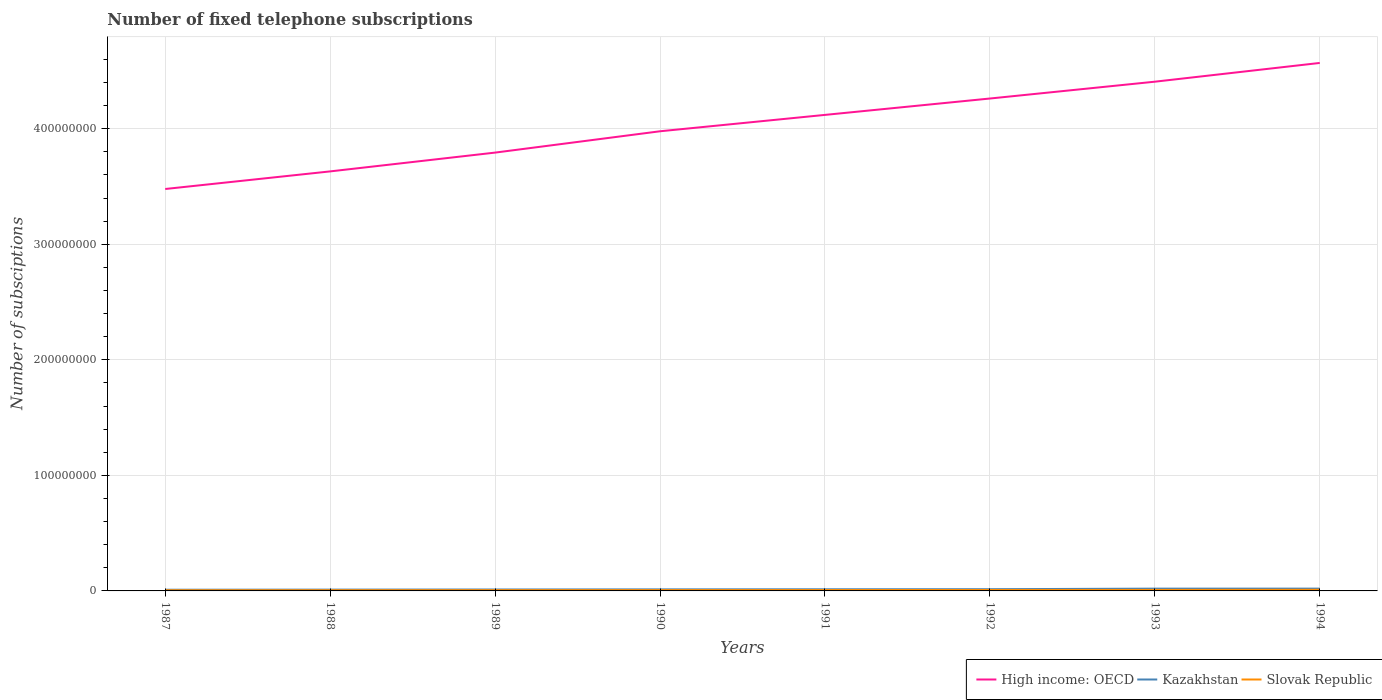Does the line corresponding to Slovak Republic intersect with the line corresponding to Kazakhstan?
Your answer should be compact. No. Is the number of lines equal to the number of legend labels?
Keep it short and to the point. Yes. Across all years, what is the maximum number of fixed telephone subscriptions in Kazakhstan?
Keep it short and to the point. 1.02e+06. In which year was the number of fixed telephone subscriptions in Slovak Republic maximum?
Your answer should be very brief. 1987. What is the total number of fixed telephone subscriptions in Slovak Republic in the graph?
Give a very brief answer. -2.99e+05. What is the difference between the highest and the second highest number of fixed telephone subscriptions in High income: OECD?
Your response must be concise. 1.09e+08. What is the difference between two consecutive major ticks on the Y-axis?
Offer a terse response. 1.00e+08. Does the graph contain any zero values?
Give a very brief answer. No. Does the graph contain grids?
Offer a very short reply. Yes. How many legend labels are there?
Your answer should be compact. 3. How are the legend labels stacked?
Ensure brevity in your answer.  Horizontal. What is the title of the graph?
Offer a very short reply. Number of fixed telephone subscriptions. Does "World" appear as one of the legend labels in the graph?
Provide a succinct answer. No. What is the label or title of the Y-axis?
Make the answer very short. Number of subsciptions. What is the Number of subsciptions of High income: OECD in 1987?
Your answer should be compact. 3.48e+08. What is the Number of subsciptions of Kazakhstan in 1987?
Your response must be concise. 1.02e+06. What is the Number of subsciptions in Slovak Republic in 1987?
Give a very brief answer. 5.94e+05. What is the Number of subsciptions in High income: OECD in 1988?
Your response must be concise. 3.63e+08. What is the Number of subsciptions of Kazakhstan in 1988?
Your response must be concise. 1.12e+06. What is the Number of subsciptions in Slovak Republic in 1988?
Provide a short and direct response. 6.29e+05. What is the Number of subsciptions in High income: OECD in 1989?
Offer a terse response. 3.79e+08. What is the Number of subsciptions in Kazakhstan in 1989?
Give a very brief answer. 1.23e+06. What is the Number of subsciptions in Slovak Republic in 1989?
Provide a succinct answer. 6.69e+05. What is the Number of subsciptions in High income: OECD in 1990?
Your answer should be compact. 3.98e+08. What is the Number of subsciptions of Kazakhstan in 1990?
Offer a very short reply. 1.33e+06. What is the Number of subsciptions in Slovak Republic in 1990?
Your answer should be compact. 7.11e+05. What is the Number of subsciptions of High income: OECD in 1991?
Provide a succinct answer. 4.12e+08. What is the Number of subsciptions of Kazakhstan in 1991?
Your answer should be compact. 1.43e+06. What is the Number of subsciptions of Slovak Republic in 1991?
Offer a terse response. 7.59e+05. What is the Number of subsciptions in High income: OECD in 1992?
Your answer should be very brief. 4.26e+08. What is the Number of subsciptions of Kazakhstan in 1992?
Ensure brevity in your answer.  1.49e+06. What is the Number of subsciptions in Slovak Republic in 1992?
Give a very brief answer. 8.21e+05. What is the Number of subsciptions in High income: OECD in 1993?
Offer a very short reply. 4.41e+08. What is the Number of subsciptions in Kazakhstan in 1993?
Your answer should be compact. 1.98e+06. What is the Number of subsciptions of Slovak Republic in 1993?
Provide a succinct answer. 8.93e+05. What is the Number of subsciptions in High income: OECD in 1994?
Your answer should be very brief. 4.57e+08. What is the Number of subsciptions of Kazakhstan in 1994?
Provide a short and direct response. 1.99e+06. What is the Number of subsciptions in Slovak Republic in 1994?
Provide a succinct answer. 1.00e+06. Across all years, what is the maximum Number of subsciptions in High income: OECD?
Provide a short and direct response. 4.57e+08. Across all years, what is the maximum Number of subsciptions of Kazakhstan?
Your answer should be compact. 1.99e+06. Across all years, what is the maximum Number of subsciptions in Slovak Republic?
Provide a succinct answer. 1.00e+06. Across all years, what is the minimum Number of subsciptions of High income: OECD?
Keep it short and to the point. 3.48e+08. Across all years, what is the minimum Number of subsciptions in Kazakhstan?
Your response must be concise. 1.02e+06. Across all years, what is the minimum Number of subsciptions in Slovak Republic?
Keep it short and to the point. 5.94e+05. What is the total Number of subsciptions in High income: OECD in the graph?
Your answer should be compact. 3.22e+09. What is the total Number of subsciptions of Kazakhstan in the graph?
Provide a short and direct response. 1.16e+07. What is the total Number of subsciptions of Slovak Republic in the graph?
Offer a very short reply. 6.08e+06. What is the difference between the Number of subsciptions in High income: OECD in 1987 and that in 1988?
Your answer should be very brief. -1.52e+07. What is the difference between the Number of subsciptions in Kazakhstan in 1987 and that in 1988?
Your answer should be compact. -9.51e+04. What is the difference between the Number of subsciptions of Slovak Republic in 1987 and that in 1988?
Give a very brief answer. -3.54e+04. What is the difference between the Number of subsciptions in High income: OECD in 1987 and that in 1989?
Offer a terse response. -3.15e+07. What is the difference between the Number of subsciptions of Kazakhstan in 1987 and that in 1989?
Keep it short and to the point. -2.02e+05. What is the difference between the Number of subsciptions of Slovak Republic in 1987 and that in 1989?
Your answer should be very brief. -7.51e+04. What is the difference between the Number of subsciptions in High income: OECD in 1987 and that in 1990?
Provide a succinct answer. -5.00e+07. What is the difference between the Number of subsciptions of Kazakhstan in 1987 and that in 1990?
Your response must be concise. -3.10e+05. What is the difference between the Number of subsciptions in Slovak Republic in 1987 and that in 1990?
Give a very brief answer. -1.17e+05. What is the difference between the Number of subsciptions in High income: OECD in 1987 and that in 1991?
Your response must be concise. -6.41e+07. What is the difference between the Number of subsciptions in Kazakhstan in 1987 and that in 1991?
Offer a very short reply. -4.01e+05. What is the difference between the Number of subsciptions of Slovak Republic in 1987 and that in 1991?
Provide a succinct answer. -1.65e+05. What is the difference between the Number of subsciptions of High income: OECD in 1987 and that in 1992?
Keep it short and to the point. -7.83e+07. What is the difference between the Number of subsciptions of Kazakhstan in 1987 and that in 1992?
Provide a short and direct response. -4.67e+05. What is the difference between the Number of subsciptions in Slovak Republic in 1987 and that in 1992?
Provide a succinct answer. -2.27e+05. What is the difference between the Number of subsciptions of High income: OECD in 1987 and that in 1993?
Your answer should be very brief. -9.29e+07. What is the difference between the Number of subsciptions in Kazakhstan in 1987 and that in 1993?
Your response must be concise. -9.52e+05. What is the difference between the Number of subsciptions of Slovak Republic in 1987 and that in 1993?
Your answer should be compact. -2.99e+05. What is the difference between the Number of subsciptions of High income: OECD in 1987 and that in 1994?
Your answer should be very brief. -1.09e+08. What is the difference between the Number of subsciptions of Kazakhstan in 1987 and that in 1994?
Offer a very short reply. -9.63e+05. What is the difference between the Number of subsciptions in Slovak Republic in 1987 and that in 1994?
Offer a terse response. -4.10e+05. What is the difference between the Number of subsciptions of High income: OECD in 1988 and that in 1989?
Give a very brief answer. -1.63e+07. What is the difference between the Number of subsciptions of Kazakhstan in 1988 and that in 1989?
Your answer should be very brief. -1.07e+05. What is the difference between the Number of subsciptions in Slovak Republic in 1988 and that in 1989?
Provide a succinct answer. -3.97e+04. What is the difference between the Number of subsciptions of High income: OECD in 1988 and that in 1990?
Your answer should be very brief. -3.47e+07. What is the difference between the Number of subsciptions of Kazakhstan in 1988 and that in 1990?
Keep it short and to the point. -2.15e+05. What is the difference between the Number of subsciptions of Slovak Republic in 1988 and that in 1990?
Your answer should be very brief. -8.17e+04. What is the difference between the Number of subsciptions in High income: OECD in 1988 and that in 1991?
Provide a succinct answer. -4.89e+07. What is the difference between the Number of subsciptions in Kazakhstan in 1988 and that in 1991?
Your answer should be compact. -3.06e+05. What is the difference between the Number of subsciptions of Slovak Republic in 1988 and that in 1991?
Offer a very short reply. -1.30e+05. What is the difference between the Number of subsciptions in High income: OECD in 1988 and that in 1992?
Offer a very short reply. -6.31e+07. What is the difference between the Number of subsciptions of Kazakhstan in 1988 and that in 1992?
Offer a terse response. -3.71e+05. What is the difference between the Number of subsciptions of Slovak Republic in 1988 and that in 1992?
Offer a very short reply. -1.92e+05. What is the difference between the Number of subsciptions of High income: OECD in 1988 and that in 1993?
Offer a very short reply. -7.76e+07. What is the difference between the Number of subsciptions in Kazakhstan in 1988 and that in 1993?
Keep it short and to the point. -8.57e+05. What is the difference between the Number of subsciptions in Slovak Republic in 1988 and that in 1993?
Provide a short and direct response. -2.64e+05. What is the difference between the Number of subsciptions in High income: OECD in 1988 and that in 1994?
Offer a terse response. -9.39e+07. What is the difference between the Number of subsciptions of Kazakhstan in 1988 and that in 1994?
Ensure brevity in your answer.  -8.68e+05. What is the difference between the Number of subsciptions of Slovak Republic in 1988 and that in 1994?
Make the answer very short. -3.75e+05. What is the difference between the Number of subsciptions in High income: OECD in 1989 and that in 1990?
Your response must be concise. -1.85e+07. What is the difference between the Number of subsciptions of Kazakhstan in 1989 and that in 1990?
Offer a terse response. -1.08e+05. What is the difference between the Number of subsciptions of Slovak Republic in 1989 and that in 1990?
Offer a very short reply. -4.19e+04. What is the difference between the Number of subsciptions in High income: OECD in 1989 and that in 1991?
Provide a short and direct response. -3.26e+07. What is the difference between the Number of subsciptions in Kazakhstan in 1989 and that in 1991?
Ensure brevity in your answer.  -2.00e+05. What is the difference between the Number of subsciptions of Slovak Republic in 1989 and that in 1991?
Your response must be concise. -9.01e+04. What is the difference between the Number of subsciptions in High income: OECD in 1989 and that in 1992?
Provide a succinct answer. -4.68e+07. What is the difference between the Number of subsciptions in Kazakhstan in 1989 and that in 1992?
Keep it short and to the point. -2.65e+05. What is the difference between the Number of subsciptions of Slovak Republic in 1989 and that in 1992?
Offer a very short reply. -1.52e+05. What is the difference between the Number of subsciptions of High income: OECD in 1989 and that in 1993?
Give a very brief answer. -6.14e+07. What is the difference between the Number of subsciptions in Kazakhstan in 1989 and that in 1993?
Your response must be concise. -7.50e+05. What is the difference between the Number of subsciptions in Slovak Republic in 1989 and that in 1993?
Keep it short and to the point. -2.24e+05. What is the difference between the Number of subsciptions in High income: OECD in 1989 and that in 1994?
Keep it short and to the point. -7.76e+07. What is the difference between the Number of subsciptions in Kazakhstan in 1989 and that in 1994?
Ensure brevity in your answer.  -7.61e+05. What is the difference between the Number of subsciptions of Slovak Republic in 1989 and that in 1994?
Provide a short and direct response. -3.35e+05. What is the difference between the Number of subsciptions in High income: OECD in 1990 and that in 1991?
Provide a succinct answer. -1.42e+07. What is the difference between the Number of subsciptions of Kazakhstan in 1990 and that in 1991?
Ensure brevity in your answer.  -9.18e+04. What is the difference between the Number of subsciptions in Slovak Republic in 1990 and that in 1991?
Ensure brevity in your answer.  -4.82e+04. What is the difference between the Number of subsciptions of High income: OECD in 1990 and that in 1992?
Provide a succinct answer. -2.84e+07. What is the difference between the Number of subsciptions of Kazakhstan in 1990 and that in 1992?
Provide a succinct answer. -1.57e+05. What is the difference between the Number of subsciptions of Slovak Republic in 1990 and that in 1992?
Your answer should be very brief. -1.10e+05. What is the difference between the Number of subsciptions in High income: OECD in 1990 and that in 1993?
Your response must be concise. -4.29e+07. What is the difference between the Number of subsciptions of Kazakhstan in 1990 and that in 1993?
Offer a very short reply. -6.42e+05. What is the difference between the Number of subsciptions in Slovak Republic in 1990 and that in 1993?
Provide a short and direct response. -1.82e+05. What is the difference between the Number of subsciptions in High income: OECD in 1990 and that in 1994?
Provide a succinct answer. -5.91e+07. What is the difference between the Number of subsciptions of Kazakhstan in 1990 and that in 1994?
Give a very brief answer. -6.54e+05. What is the difference between the Number of subsciptions in Slovak Republic in 1990 and that in 1994?
Ensure brevity in your answer.  -2.93e+05. What is the difference between the Number of subsciptions of High income: OECD in 1991 and that in 1992?
Offer a very short reply. -1.42e+07. What is the difference between the Number of subsciptions in Kazakhstan in 1991 and that in 1992?
Ensure brevity in your answer.  -6.52e+04. What is the difference between the Number of subsciptions in Slovak Republic in 1991 and that in 1992?
Your response must be concise. -6.19e+04. What is the difference between the Number of subsciptions of High income: OECD in 1991 and that in 1993?
Offer a terse response. -2.87e+07. What is the difference between the Number of subsciptions in Kazakhstan in 1991 and that in 1993?
Provide a succinct answer. -5.51e+05. What is the difference between the Number of subsciptions of Slovak Republic in 1991 and that in 1993?
Keep it short and to the point. -1.34e+05. What is the difference between the Number of subsciptions of High income: OECD in 1991 and that in 1994?
Provide a succinct answer. -4.50e+07. What is the difference between the Number of subsciptions of Kazakhstan in 1991 and that in 1994?
Your response must be concise. -5.62e+05. What is the difference between the Number of subsciptions of Slovak Republic in 1991 and that in 1994?
Give a very brief answer. -2.45e+05. What is the difference between the Number of subsciptions of High income: OECD in 1992 and that in 1993?
Give a very brief answer. -1.46e+07. What is the difference between the Number of subsciptions in Kazakhstan in 1992 and that in 1993?
Keep it short and to the point. -4.85e+05. What is the difference between the Number of subsciptions of Slovak Republic in 1992 and that in 1993?
Keep it short and to the point. -7.19e+04. What is the difference between the Number of subsciptions of High income: OECD in 1992 and that in 1994?
Give a very brief answer. -3.08e+07. What is the difference between the Number of subsciptions in Kazakhstan in 1992 and that in 1994?
Give a very brief answer. -4.97e+05. What is the difference between the Number of subsciptions of Slovak Republic in 1992 and that in 1994?
Keep it short and to the point. -1.83e+05. What is the difference between the Number of subsciptions of High income: OECD in 1993 and that in 1994?
Offer a very short reply. -1.62e+07. What is the difference between the Number of subsciptions in Kazakhstan in 1993 and that in 1994?
Keep it short and to the point. -1.12e+04. What is the difference between the Number of subsciptions of Slovak Republic in 1993 and that in 1994?
Offer a terse response. -1.11e+05. What is the difference between the Number of subsciptions in High income: OECD in 1987 and the Number of subsciptions in Kazakhstan in 1988?
Offer a very short reply. 3.47e+08. What is the difference between the Number of subsciptions of High income: OECD in 1987 and the Number of subsciptions of Slovak Republic in 1988?
Your response must be concise. 3.47e+08. What is the difference between the Number of subsciptions in Kazakhstan in 1987 and the Number of subsciptions in Slovak Republic in 1988?
Make the answer very short. 3.95e+05. What is the difference between the Number of subsciptions of High income: OECD in 1987 and the Number of subsciptions of Kazakhstan in 1989?
Provide a short and direct response. 3.47e+08. What is the difference between the Number of subsciptions of High income: OECD in 1987 and the Number of subsciptions of Slovak Republic in 1989?
Provide a succinct answer. 3.47e+08. What is the difference between the Number of subsciptions in Kazakhstan in 1987 and the Number of subsciptions in Slovak Republic in 1989?
Provide a short and direct response. 3.55e+05. What is the difference between the Number of subsciptions in High income: OECD in 1987 and the Number of subsciptions in Kazakhstan in 1990?
Give a very brief answer. 3.47e+08. What is the difference between the Number of subsciptions of High income: OECD in 1987 and the Number of subsciptions of Slovak Republic in 1990?
Offer a terse response. 3.47e+08. What is the difference between the Number of subsciptions in Kazakhstan in 1987 and the Number of subsciptions in Slovak Republic in 1990?
Your response must be concise. 3.13e+05. What is the difference between the Number of subsciptions in High income: OECD in 1987 and the Number of subsciptions in Kazakhstan in 1991?
Make the answer very short. 3.46e+08. What is the difference between the Number of subsciptions of High income: OECD in 1987 and the Number of subsciptions of Slovak Republic in 1991?
Provide a short and direct response. 3.47e+08. What is the difference between the Number of subsciptions of Kazakhstan in 1987 and the Number of subsciptions of Slovak Republic in 1991?
Your answer should be compact. 2.65e+05. What is the difference between the Number of subsciptions in High income: OECD in 1987 and the Number of subsciptions in Kazakhstan in 1992?
Keep it short and to the point. 3.46e+08. What is the difference between the Number of subsciptions in High income: OECD in 1987 and the Number of subsciptions in Slovak Republic in 1992?
Give a very brief answer. 3.47e+08. What is the difference between the Number of subsciptions in Kazakhstan in 1987 and the Number of subsciptions in Slovak Republic in 1992?
Your answer should be compact. 2.03e+05. What is the difference between the Number of subsciptions in High income: OECD in 1987 and the Number of subsciptions in Kazakhstan in 1993?
Keep it short and to the point. 3.46e+08. What is the difference between the Number of subsciptions of High income: OECD in 1987 and the Number of subsciptions of Slovak Republic in 1993?
Ensure brevity in your answer.  3.47e+08. What is the difference between the Number of subsciptions of Kazakhstan in 1987 and the Number of subsciptions of Slovak Republic in 1993?
Provide a succinct answer. 1.31e+05. What is the difference between the Number of subsciptions in High income: OECD in 1987 and the Number of subsciptions in Kazakhstan in 1994?
Make the answer very short. 3.46e+08. What is the difference between the Number of subsciptions in High income: OECD in 1987 and the Number of subsciptions in Slovak Republic in 1994?
Provide a succinct answer. 3.47e+08. What is the difference between the Number of subsciptions of Kazakhstan in 1987 and the Number of subsciptions of Slovak Republic in 1994?
Make the answer very short. 2.00e+04. What is the difference between the Number of subsciptions in High income: OECD in 1988 and the Number of subsciptions in Kazakhstan in 1989?
Offer a terse response. 3.62e+08. What is the difference between the Number of subsciptions in High income: OECD in 1988 and the Number of subsciptions in Slovak Republic in 1989?
Your answer should be very brief. 3.62e+08. What is the difference between the Number of subsciptions in Kazakhstan in 1988 and the Number of subsciptions in Slovak Republic in 1989?
Ensure brevity in your answer.  4.50e+05. What is the difference between the Number of subsciptions in High income: OECD in 1988 and the Number of subsciptions in Kazakhstan in 1990?
Make the answer very short. 3.62e+08. What is the difference between the Number of subsciptions of High income: OECD in 1988 and the Number of subsciptions of Slovak Republic in 1990?
Keep it short and to the point. 3.62e+08. What is the difference between the Number of subsciptions of Kazakhstan in 1988 and the Number of subsciptions of Slovak Republic in 1990?
Offer a very short reply. 4.08e+05. What is the difference between the Number of subsciptions of High income: OECD in 1988 and the Number of subsciptions of Kazakhstan in 1991?
Keep it short and to the point. 3.62e+08. What is the difference between the Number of subsciptions of High income: OECD in 1988 and the Number of subsciptions of Slovak Republic in 1991?
Keep it short and to the point. 3.62e+08. What is the difference between the Number of subsciptions in Kazakhstan in 1988 and the Number of subsciptions in Slovak Republic in 1991?
Give a very brief answer. 3.60e+05. What is the difference between the Number of subsciptions in High income: OECD in 1988 and the Number of subsciptions in Kazakhstan in 1992?
Your response must be concise. 3.62e+08. What is the difference between the Number of subsciptions of High income: OECD in 1988 and the Number of subsciptions of Slovak Republic in 1992?
Make the answer very short. 3.62e+08. What is the difference between the Number of subsciptions of Kazakhstan in 1988 and the Number of subsciptions of Slovak Republic in 1992?
Give a very brief answer. 2.98e+05. What is the difference between the Number of subsciptions of High income: OECD in 1988 and the Number of subsciptions of Kazakhstan in 1993?
Provide a succinct answer. 3.61e+08. What is the difference between the Number of subsciptions of High income: OECD in 1988 and the Number of subsciptions of Slovak Republic in 1993?
Your answer should be compact. 3.62e+08. What is the difference between the Number of subsciptions of Kazakhstan in 1988 and the Number of subsciptions of Slovak Republic in 1993?
Provide a short and direct response. 2.26e+05. What is the difference between the Number of subsciptions in High income: OECD in 1988 and the Number of subsciptions in Kazakhstan in 1994?
Offer a terse response. 3.61e+08. What is the difference between the Number of subsciptions in High income: OECD in 1988 and the Number of subsciptions in Slovak Republic in 1994?
Your response must be concise. 3.62e+08. What is the difference between the Number of subsciptions of Kazakhstan in 1988 and the Number of subsciptions of Slovak Republic in 1994?
Give a very brief answer. 1.15e+05. What is the difference between the Number of subsciptions of High income: OECD in 1989 and the Number of subsciptions of Kazakhstan in 1990?
Provide a short and direct response. 3.78e+08. What is the difference between the Number of subsciptions of High income: OECD in 1989 and the Number of subsciptions of Slovak Republic in 1990?
Give a very brief answer. 3.79e+08. What is the difference between the Number of subsciptions in Kazakhstan in 1989 and the Number of subsciptions in Slovak Republic in 1990?
Provide a succinct answer. 5.15e+05. What is the difference between the Number of subsciptions of High income: OECD in 1989 and the Number of subsciptions of Kazakhstan in 1991?
Make the answer very short. 3.78e+08. What is the difference between the Number of subsciptions in High income: OECD in 1989 and the Number of subsciptions in Slovak Republic in 1991?
Your answer should be compact. 3.79e+08. What is the difference between the Number of subsciptions in Kazakhstan in 1989 and the Number of subsciptions in Slovak Republic in 1991?
Offer a terse response. 4.67e+05. What is the difference between the Number of subsciptions in High income: OECD in 1989 and the Number of subsciptions in Kazakhstan in 1992?
Ensure brevity in your answer.  3.78e+08. What is the difference between the Number of subsciptions in High income: OECD in 1989 and the Number of subsciptions in Slovak Republic in 1992?
Your answer should be compact. 3.79e+08. What is the difference between the Number of subsciptions of Kazakhstan in 1989 and the Number of subsciptions of Slovak Republic in 1992?
Offer a very short reply. 4.05e+05. What is the difference between the Number of subsciptions of High income: OECD in 1989 and the Number of subsciptions of Kazakhstan in 1993?
Offer a very short reply. 3.77e+08. What is the difference between the Number of subsciptions in High income: OECD in 1989 and the Number of subsciptions in Slovak Republic in 1993?
Offer a terse response. 3.78e+08. What is the difference between the Number of subsciptions in Kazakhstan in 1989 and the Number of subsciptions in Slovak Republic in 1993?
Your answer should be compact. 3.33e+05. What is the difference between the Number of subsciptions of High income: OECD in 1989 and the Number of subsciptions of Kazakhstan in 1994?
Ensure brevity in your answer.  3.77e+08. What is the difference between the Number of subsciptions in High income: OECD in 1989 and the Number of subsciptions in Slovak Republic in 1994?
Offer a very short reply. 3.78e+08. What is the difference between the Number of subsciptions in Kazakhstan in 1989 and the Number of subsciptions in Slovak Republic in 1994?
Your answer should be very brief. 2.22e+05. What is the difference between the Number of subsciptions in High income: OECD in 1990 and the Number of subsciptions in Kazakhstan in 1991?
Ensure brevity in your answer.  3.96e+08. What is the difference between the Number of subsciptions in High income: OECD in 1990 and the Number of subsciptions in Slovak Republic in 1991?
Provide a short and direct response. 3.97e+08. What is the difference between the Number of subsciptions in Kazakhstan in 1990 and the Number of subsciptions in Slovak Republic in 1991?
Offer a very short reply. 5.74e+05. What is the difference between the Number of subsciptions in High income: OECD in 1990 and the Number of subsciptions in Kazakhstan in 1992?
Make the answer very short. 3.96e+08. What is the difference between the Number of subsciptions in High income: OECD in 1990 and the Number of subsciptions in Slovak Republic in 1992?
Ensure brevity in your answer.  3.97e+08. What is the difference between the Number of subsciptions in Kazakhstan in 1990 and the Number of subsciptions in Slovak Republic in 1992?
Offer a very short reply. 5.13e+05. What is the difference between the Number of subsciptions in High income: OECD in 1990 and the Number of subsciptions in Kazakhstan in 1993?
Offer a terse response. 3.96e+08. What is the difference between the Number of subsciptions of High income: OECD in 1990 and the Number of subsciptions of Slovak Republic in 1993?
Give a very brief answer. 3.97e+08. What is the difference between the Number of subsciptions in Kazakhstan in 1990 and the Number of subsciptions in Slovak Republic in 1993?
Offer a very short reply. 4.41e+05. What is the difference between the Number of subsciptions of High income: OECD in 1990 and the Number of subsciptions of Kazakhstan in 1994?
Ensure brevity in your answer.  3.96e+08. What is the difference between the Number of subsciptions of High income: OECD in 1990 and the Number of subsciptions of Slovak Republic in 1994?
Give a very brief answer. 3.97e+08. What is the difference between the Number of subsciptions in Kazakhstan in 1990 and the Number of subsciptions in Slovak Republic in 1994?
Your answer should be compact. 3.30e+05. What is the difference between the Number of subsciptions of High income: OECD in 1991 and the Number of subsciptions of Kazakhstan in 1992?
Your answer should be compact. 4.11e+08. What is the difference between the Number of subsciptions in High income: OECD in 1991 and the Number of subsciptions in Slovak Republic in 1992?
Your response must be concise. 4.11e+08. What is the difference between the Number of subsciptions in Kazakhstan in 1991 and the Number of subsciptions in Slovak Republic in 1992?
Provide a succinct answer. 6.04e+05. What is the difference between the Number of subsciptions of High income: OECD in 1991 and the Number of subsciptions of Kazakhstan in 1993?
Offer a terse response. 4.10e+08. What is the difference between the Number of subsciptions in High income: OECD in 1991 and the Number of subsciptions in Slovak Republic in 1993?
Offer a very short reply. 4.11e+08. What is the difference between the Number of subsciptions of Kazakhstan in 1991 and the Number of subsciptions of Slovak Republic in 1993?
Your answer should be compact. 5.32e+05. What is the difference between the Number of subsciptions in High income: OECD in 1991 and the Number of subsciptions in Kazakhstan in 1994?
Ensure brevity in your answer.  4.10e+08. What is the difference between the Number of subsciptions in High income: OECD in 1991 and the Number of subsciptions in Slovak Republic in 1994?
Keep it short and to the point. 4.11e+08. What is the difference between the Number of subsciptions in Kazakhstan in 1991 and the Number of subsciptions in Slovak Republic in 1994?
Keep it short and to the point. 4.21e+05. What is the difference between the Number of subsciptions of High income: OECD in 1992 and the Number of subsciptions of Kazakhstan in 1993?
Your answer should be compact. 4.24e+08. What is the difference between the Number of subsciptions of High income: OECD in 1992 and the Number of subsciptions of Slovak Republic in 1993?
Ensure brevity in your answer.  4.25e+08. What is the difference between the Number of subsciptions of Kazakhstan in 1992 and the Number of subsciptions of Slovak Republic in 1993?
Your response must be concise. 5.98e+05. What is the difference between the Number of subsciptions in High income: OECD in 1992 and the Number of subsciptions in Kazakhstan in 1994?
Your response must be concise. 4.24e+08. What is the difference between the Number of subsciptions of High income: OECD in 1992 and the Number of subsciptions of Slovak Republic in 1994?
Your response must be concise. 4.25e+08. What is the difference between the Number of subsciptions in Kazakhstan in 1992 and the Number of subsciptions in Slovak Republic in 1994?
Provide a short and direct response. 4.87e+05. What is the difference between the Number of subsciptions in High income: OECD in 1993 and the Number of subsciptions in Kazakhstan in 1994?
Provide a succinct answer. 4.39e+08. What is the difference between the Number of subsciptions in High income: OECD in 1993 and the Number of subsciptions in Slovak Republic in 1994?
Your answer should be very brief. 4.40e+08. What is the difference between the Number of subsciptions of Kazakhstan in 1993 and the Number of subsciptions of Slovak Republic in 1994?
Ensure brevity in your answer.  9.72e+05. What is the average Number of subsciptions in High income: OECD per year?
Provide a short and direct response. 4.03e+08. What is the average Number of subsciptions in Kazakhstan per year?
Provide a short and direct response. 1.45e+06. What is the average Number of subsciptions in Slovak Republic per year?
Keep it short and to the point. 7.60e+05. In the year 1987, what is the difference between the Number of subsciptions of High income: OECD and Number of subsciptions of Kazakhstan?
Keep it short and to the point. 3.47e+08. In the year 1987, what is the difference between the Number of subsciptions of High income: OECD and Number of subsciptions of Slovak Republic?
Keep it short and to the point. 3.47e+08. In the year 1987, what is the difference between the Number of subsciptions of Kazakhstan and Number of subsciptions of Slovak Republic?
Make the answer very short. 4.30e+05. In the year 1988, what is the difference between the Number of subsciptions of High income: OECD and Number of subsciptions of Kazakhstan?
Give a very brief answer. 3.62e+08. In the year 1988, what is the difference between the Number of subsciptions of High income: OECD and Number of subsciptions of Slovak Republic?
Offer a very short reply. 3.62e+08. In the year 1988, what is the difference between the Number of subsciptions in Kazakhstan and Number of subsciptions in Slovak Republic?
Offer a very short reply. 4.90e+05. In the year 1989, what is the difference between the Number of subsciptions in High income: OECD and Number of subsciptions in Kazakhstan?
Make the answer very short. 3.78e+08. In the year 1989, what is the difference between the Number of subsciptions of High income: OECD and Number of subsciptions of Slovak Republic?
Offer a very short reply. 3.79e+08. In the year 1989, what is the difference between the Number of subsciptions in Kazakhstan and Number of subsciptions in Slovak Republic?
Your answer should be compact. 5.57e+05. In the year 1990, what is the difference between the Number of subsciptions in High income: OECD and Number of subsciptions in Kazakhstan?
Provide a succinct answer. 3.96e+08. In the year 1990, what is the difference between the Number of subsciptions in High income: OECD and Number of subsciptions in Slovak Republic?
Your answer should be compact. 3.97e+08. In the year 1990, what is the difference between the Number of subsciptions in Kazakhstan and Number of subsciptions in Slovak Republic?
Give a very brief answer. 6.23e+05. In the year 1991, what is the difference between the Number of subsciptions of High income: OECD and Number of subsciptions of Kazakhstan?
Your response must be concise. 4.11e+08. In the year 1991, what is the difference between the Number of subsciptions of High income: OECD and Number of subsciptions of Slovak Republic?
Ensure brevity in your answer.  4.11e+08. In the year 1991, what is the difference between the Number of subsciptions of Kazakhstan and Number of subsciptions of Slovak Republic?
Provide a short and direct response. 6.66e+05. In the year 1992, what is the difference between the Number of subsciptions of High income: OECD and Number of subsciptions of Kazakhstan?
Your answer should be very brief. 4.25e+08. In the year 1992, what is the difference between the Number of subsciptions of High income: OECD and Number of subsciptions of Slovak Republic?
Ensure brevity in your answer.  4.25e+08. In the year 1992, what is the difference between the Number of subsciptions of Kazakhstan and Number of subsciptions of Slovak Republic?
Give a very brief answer. 6.70e+05. In the year 1993, what is the difference between the Number of subsciptions of High income: OECD and Number of subsciptions of Kazakhstan?
Provide a succinct answer. 4.39e+08. In the year 1993, what is the difference between the Number of subsciptions in High income: OECD and Number of subsciptions in Slovak Republic?
Keep it short and to the point. 4.40e+08. In the year 1993, what is the difference between the Number of subsciptions in Kazakhstan and Number of subsciptions in Slovak Republic?
Offer a very short reply. 1.08e+06. In the year 1994, what is the difference between the Number of subsciptions in High income: OECD and Number of subsciptions in Kazakhstan?
Ensure brevity in your answer.  4.55e+08. In the year 1994, what is the difference between the Number of subsciptions in High income: OECD and Number of subsciptions in Slovak Republic?
Offer a terse response. 4.56e+08. In the year 1994, what is the difference between the Number of subsciptions in Kazakhstan and Number of subsciptions in Slovak Republic?
Your response must be concise. 9.83e+05. What is the ratio of the Number of subsciptions of High income: OECD in 1987 to that in 1988?
Make the answer very short. 0.96. What is the ratio of the Number of subsciptions of Kazakhstan in 1987 to that in 1988?
Provide a succinct answer. 0.92. What is the ratio of the Number of subsciptions of Slovak Republic in 1987 to that in 1988?
Provide a short and direct response. 0.94. What is the ratio of the Number of subsciptions of High income: OECD in 1987 to that in 1989?
Offer a very short reply. 0.92. What is the ratio of the Number of subsciptions of Kazakhstan in 1987 to that in 1989?
Make the answer very short. 0.84. What is the ratio of the Number of subsciptions of Slovak Republic in 1987 to that in 1989?
Ensure brevity in your answer.  0.89. What is the ratio of the Number of subsciptions of High income: OECD in 1987 to that in 1990?
Keep it short and to the point. 0.87. What is the ratio of the Number of subsciptions in Kazakhstan in 1987 to that in 1990?
Your response must be concise. 0.77. What is the ratio of the Number of subsciptions in Slovak Republic in 1987 to that in 1990?
Your response must be concise. 0.84. What is the ratio of the Number of subsciptions in High income: OECD in 1987 to that in 1991?
Your answer should be compact. 0.84. What is the ratio of the Number of subsciptions in Kazakhstan in 1987 to that in 1991?
Your answer should be compact. 0.72. What is the ratio of the Number of subsciptions in Slovak Republic in 1987 to that in 1991?
Your answer should be very brief. 0.78. What is the ratio of the Number of subsciptions in High income: OECD in 1987 to that in 1992?
Make the answer very short. 0.82. What is the ratio of the Number of subsciptions in Kazakhstan in 1987 to that in 1992?
Your answer should be very brief. 0.69. What is the ratio of the Number of subsciptions of Slovak Republic in 1987 to that in 1992?
Your answer should be compact. 0.72. What is the ratio of the Number of subsciptions in High income: OECD in 1987 to that in 1993?
Offer a terse response. 0.79. What is the ratio of the Number of subsciptions in Kazakhstan in 1987 to that in 1993?
Your answer should be very brief. 0.52. What is the ratio of the Number of subsciptions in Slovak Republic in 1987 to that in 1993?
Your response must be concise. 0.67. What is the ratio of the Number of subsciptions of High income: OECD in 1987 to that in 1994?
Your response must be concise. 0.76. What is the ratio of the Number of subsciptions in Kazakhstan in 1987 to that in 1994?
Make the answer very short. 0.52. What is the ratio of the Number of subsciptions of Slovak Republic in 1987 to that in 1994?
Offer a terse response. 0.59. What is the ratio of the Number of subsciptions in High income: OECD in 1988 to that in 1989?
Your answer should be very brief. 0.96. What is the ratio of the Number of subsciptions in Slovak Republic in 1988 to that in 1989?
Your answer should be compact. 0.94. What is the ratio of the Number of subsciptions in High income: OECD in 1988 to that in 1990?
Give a very brief answer. 0.91. What is the ratio of the Number of subsciptions in Kazakhstan in 1988 to that in 1990?
Your answer should be compact. 0.84. What is the ratio of the Number of subsciptions of Slovak Republic in 1988 to that in 1990?
Provide a short and direct response. 0.89. What is the ratio of the Number of subsciptions in High income: OECD in 1988 to that in 1991?
Your answer should be very brief. 0.88. What is the ratio of the Number of subsciptions in Kazakhstan in 1988 to that in 1991?
Your answer should be compact. 0.79. What is the ratio of the Number of subsciptions in Slovak Republic in 1988 to that in 1991?
Make the answer very short. 0.83. What is the ratio of the Number of subsciptions in High income: OECD in 1988 to that in 1992?
Keep it short and to the point. 0.85. What is the ratio of the Number of subsciptions of Kazakhstan in 1988 to that in 1992?
Your answer should be very brief. 0.75. What is the ratio of the Number of subsciptions of Slovak Republic in 1988 to that in 1992?
Keep it short and to the point. 0.77. What is the ratio of the Number of subsciptions in High income: OECD in 1988 to that in 1993?
Offer a very short reply. 0.82. What is the ratio of the Number of subsciptions in Kazakhstan in 1988 to that in 1993?
Your answer should be compact. 0.57. What is the ratio of the Number of subsciptions of Slovak Republic in 1988 to that in 1993?
Offer a very short reply. 0.7. What is the ratio of the Number of subsciptions of High income: OECD in 1988 to that in 1994?
Provide a succinct answer. 0.79. What is the ratio of the Number of subsciptions of Kazakhstan in 1988 to that in 1994?
Make the answer very short. 0.56. What is the ratio of the Number of subsciptions in Slovak Republic in 1988 to that in 1994?
Your answer should be compact. 0.63. What is the ratio of the Number of subsciptions in High income: OECD in 1989 to that in 1990?
Provide a succinct answer. 0.95. What is the ratio of the Number of subsciptions of Kazakhstan in 1989 to that in 1990?
Provide a succinct answer. 0.92. What is the ratio of the Number of subsciptions in Slovak Republic in 1989 to that in 1990?
Your answer should be compact. 0.94. What is the ratio of the Number of subsciptions of High income: OECD in 1989 to that in 1991?
Your response must be concise. 0.92. What is the ratio of the Number of subsciptions in Kazakhstan in 1989 to that in 1991?
Your answer should be compact. 0.86. What is the ratio of the Number of subsciptions of Slovak Republic in 1989 to that in 1991?
Ensure brevity in your answer.  0.88. What is the ratio of the Number of subsciptions in High income: OECD in 1989 to that in 1992?
Offer a terse response. 0.89. What is the ratio of the Number of subsciptions in Kazakhstan in 1989 to that in 1992?
Keep it short and to the point. 0.82. What is the ratio of the Number of subsciptions in Slovak Republic in 1989 to that in 1992?
Offer a terse response. 0.81. What is the ratio of the Number of subsciptions of High income: OECD in 1989 to that in 1993?
Your answer should be very brief. 0.86. What is the ratio of the Number of subsciptions in Kazakhstan in 1989 to that in 1993?
Your answer should be very brief. 0.62. What is the ratio of the Number of subsciptions of Slovak Republic in 1989 to that in 1993?
Your response must be concise. 0.75. What is the ratio of the Number of subsciptions in High income: OECD in 1989 to that in 1994?
Make the answer very short. 0.83. What is the ratio of the Number of subsciptions in Kazakhstan in 1989 to that in 1994?
Provide a succinct answer. 0.62. What is the ratio of the Number of subsciptions in Slovak Republic in 1989 to that in 1994?
Your response must be concise. 0.67. What is the ratio of the Number of subsciptions in High income: OECD in 1990 to that in 1991?
Provide a short and direct response. 0.97. What is the ratio of the Number of subsciptions of Kazakhstan in 1990 to that in 1991?
Your answer should be very brief. 0.94. What is the ratio of the Number of subsciptions of Slovak Republic in 1990 to that in 1991?
Your response must be concise. 0.94. What is the ratio of the Number of subsciptions of High income: OECD in 1990 to that in 1992?
Your response must be concise. 0.93. What is the ratio of the Number of subsciptions in Kazakhstan in 1990 to that in 1992?
Your answer should be very brief. 0.89. What is the ratio of the Number of subsciptions in Slovak Republic in 1990 to that in 1992?
Provide a succinct answer. 0.87. What is the ratio of the Number of subsciptions in High income: OECD in 1990 to that in 1993?
Your answer should be very brief. 0.9. What is the ratio of the Number of subsciptions in Kazakhstan in 1990 to that in 1993?
Make the answer very short. 0.67. What is the ratio of the Number of subsciptions in Slovak Republic in 1990 to that in 1993?
Your response must be concise. 0.8. What is the ratio of the Number of subsciptions in High income: OECD in 1990 to that in 1994?
Make the answer very short. 0.87. What is the ratio of the Number of subsciptions in Kazakhstan in 1990 to that in 1994?
Your response must be concise. 0.67. What is the ratio of the Number of subsciptions in Slovak Republic in 1990 to that in 1994?
Your answer should be compact. 0.71. What is the ratio of the Number of subsciptions of High income: OECD in 1991 to that in 1992?
Offer a terse response. 0.97. What is the ratio of the Number of subsciptions in Kazakhstan in 1991 to that in 1992?
Ensure brevity in your answer.  0.96. What is the ratio of the Number of subsciptions in Slovak Republic in 1991 to that in 1992?
Your answer should be compact. 0.92. What is the ratio of the Number of subsciptions of High income: OECD in 1991 to that in 1993?
Offer a very short reply. 0.93. What is the ratio of the Number of subsciptions of Kazakhstan in 1991 to that in 1993?
Offer a very short reply. 0.72. What is the ratio of the Number of subsciptions of Slovak Republic in 1991 to that in 1993?
Give a very brief answer. 0.85. What is the ratio of the Number of subsciptions in High income: OECD in 1991 to that in 1994?
Your response must be concise. 0.9. What is the ratio of the Number of subsciptions in Kazakhstan in 1991 to that in 1994?
Your response must be concise. 0.72. What is the ratio of the Number of subsciptions of Slovak Republic in 1991 to that in 1994?
Offer a very short reply. 0.76. What is the ratio of the Number of subsciptions in Kazakhstan in 1992 to that in 1993?
Give a very brief answer. 0.75. What is the ratio of the Number of subsciptions in Slovak Republic in 1992 to that in 1993?
Ensure brevity in your answer.  0.92. What is the ratio of the Number of subsciptions in High income: OECD in 1992 to that in 1994?
Your answer should be compact. 0.93. What is the ratio of the Number of subsciptions of Kazakhstan in 1992 to that in 1994?
Provide a short and direct response. 0.75. What is the ratio of the Number of subsciptions in Slovak Republic in 1992 to that in 1994?
Offer a terse response. 0.82. What is the ratio of the Number of subsciptions of High income: OECD in 1993 to that in 1994?
Offer a very short reply. 0.96. What is the ratio of the Number of subsciptions in Slovak Republic in 1993 to that in 1994?
Make the answer very short. 0.89. What is the difference between the highest and the second highest Number of subsciptions of High income: OECD?
Keep it short and to the point. 1.62e+07. What is the difference between the highest and the second highest Number of subsciptions of Kazakhstan?
Offer a terse response. 1.12e+04. What is the difference between the highest and the second highest Number of subsciptions in Slovak Republic?
Your answer should be compact. 1.11e+05. What is the difference between the highest and the lowest Number of subsciptions of High income: OECD?
Make the answer very short. 1.09e+08. What is the difference between the highest and the lowest Number of subsciptions of Kazakhstan?
Ensure brevity in your answer.  9.63e+05. What is the difference between the highest and the lowest Number of subsciptions of Slovak Republic?
Your response must be concise. 4.10e+05. 